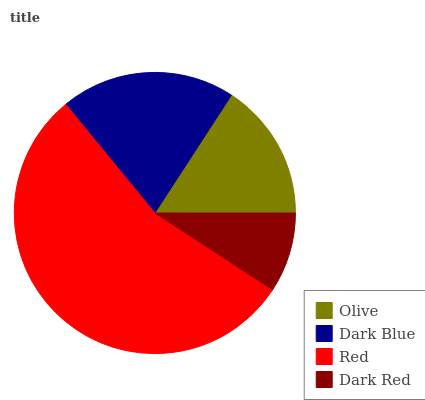Is Dark Red the minimum?
Answer yes or no. Yes. Is Red the maximum?
Answer yes or no. Yes. Is Dark Blue the minimum?
Answer yes or no. No. Is Dark Blue the maximum?
Answer yes or no. No. Is Dark Blue greater than Olive?
Answer yes or no. Yes. Is Olive less than Dark Blue?
Answer yes or no. Yes. Is Olive greater than Dark Blue?
Answer yes or no. No. Is Dark Blue less than Olive?
Answer yes or no. No. Is Dark Blue the high median?
Answer yes or no. Yes. Is Olive the low median?
Answer yes or no. Yes. Is Red the high median?
Answer yes or no. No. Is Red the low median?
Answer yes or no. No. 